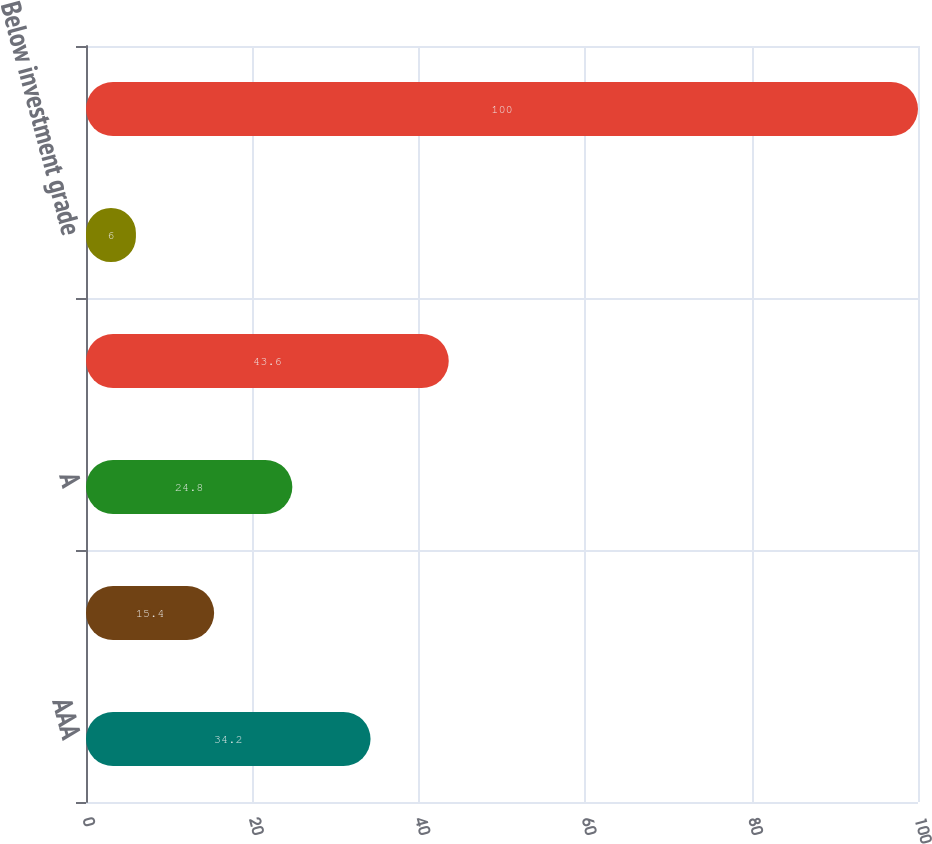<chart> <loc_0><loc_0><loc_500><loc_500><bar_chart><fcel>AAA<fcel>AA<fcel>A<fcel>BBB<fcel>Below investment grade<fcel>Total fixed maturities<nl><fcel>34.2<fcel>15.4<fcel>24.8<fcel>43.6<fcel>6<fcel>100<nl></chart> 